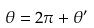Convert formula to latex. <formula><loc_0><loc_0><loc_500><loc_500>\theta = 2 \pi + \theta ^ { \prime }</formula> 